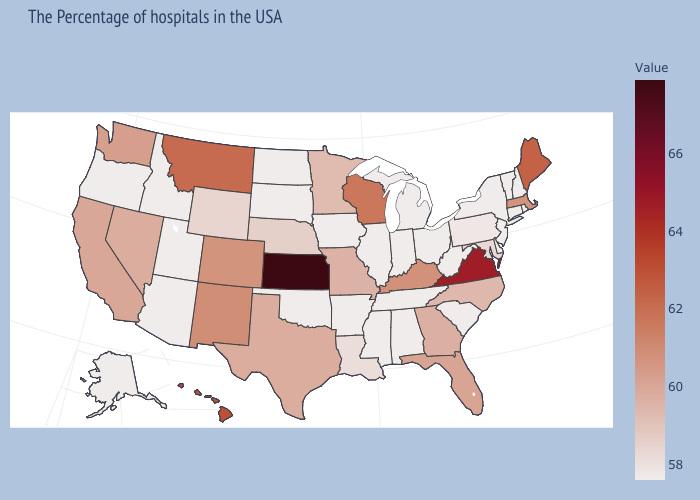Among the states that border Connecticut , does Massachusetts have the highest value?
Answer briefly. Yes. Which states have the highest value in the USA?
Short answer required. Kansas. Does Louisiana have a lower value than Maine?
Be succinct. Yes. Does Montana have the lowest value in the USA?
Short answer required. No. Which states hav the highest value in the South?
Give a very brief answer. Virginia. Which states hav the highest value in the West?
Short answer required. Hawaii. 